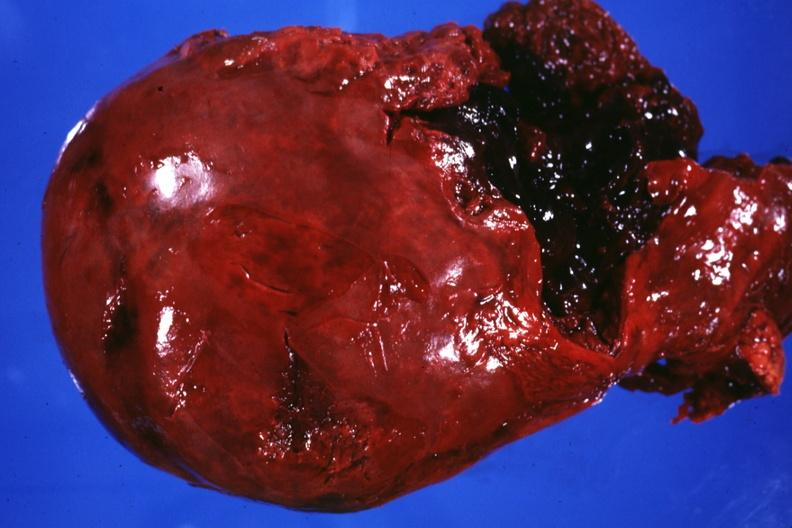where does this image show external view of liver severe laceration?
Answer the question using a single word or phrase. Between lobes 